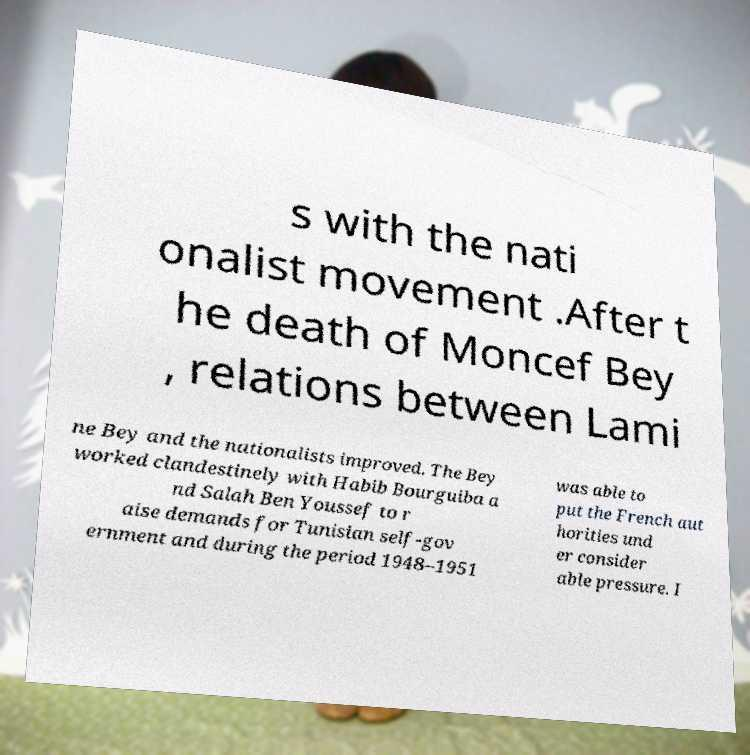There's text embedded in this image that I need extracted. Can you transcribe it verbatim? s with the nati onalist movement .After t he death of Moncef Bey , relations between Lami ne Bey and the nationalists improved. The Bey worked clandestinely with Habib Bourguiba a nd Salah Ben Youssef to r aise demands for Tunisian self-gov ernment and during the period 1948–1951 was able to put the French aut horities und er consider able pressure. I 